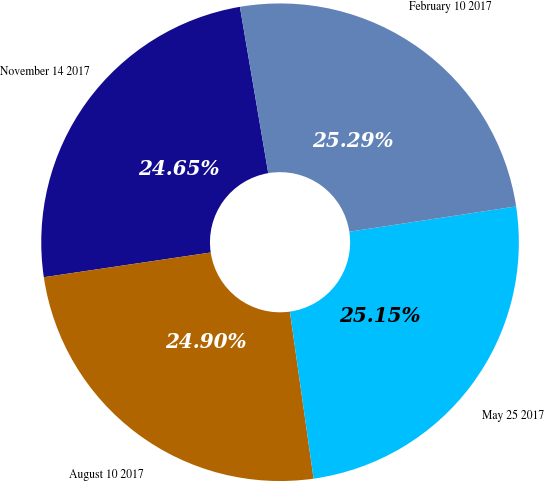Convert chart to OTSL. <chart><loc_0><loc_0><loc_500><loc_500><pie_chart><fcel>November 14 2017<fcel>August 10 2017<fcel>May 25 2017<fcel>February 10 2017<nl><fcel>24.65%<fcel>24.9%<fcel>25.15%<fcel>25.29%<nl></chart> 